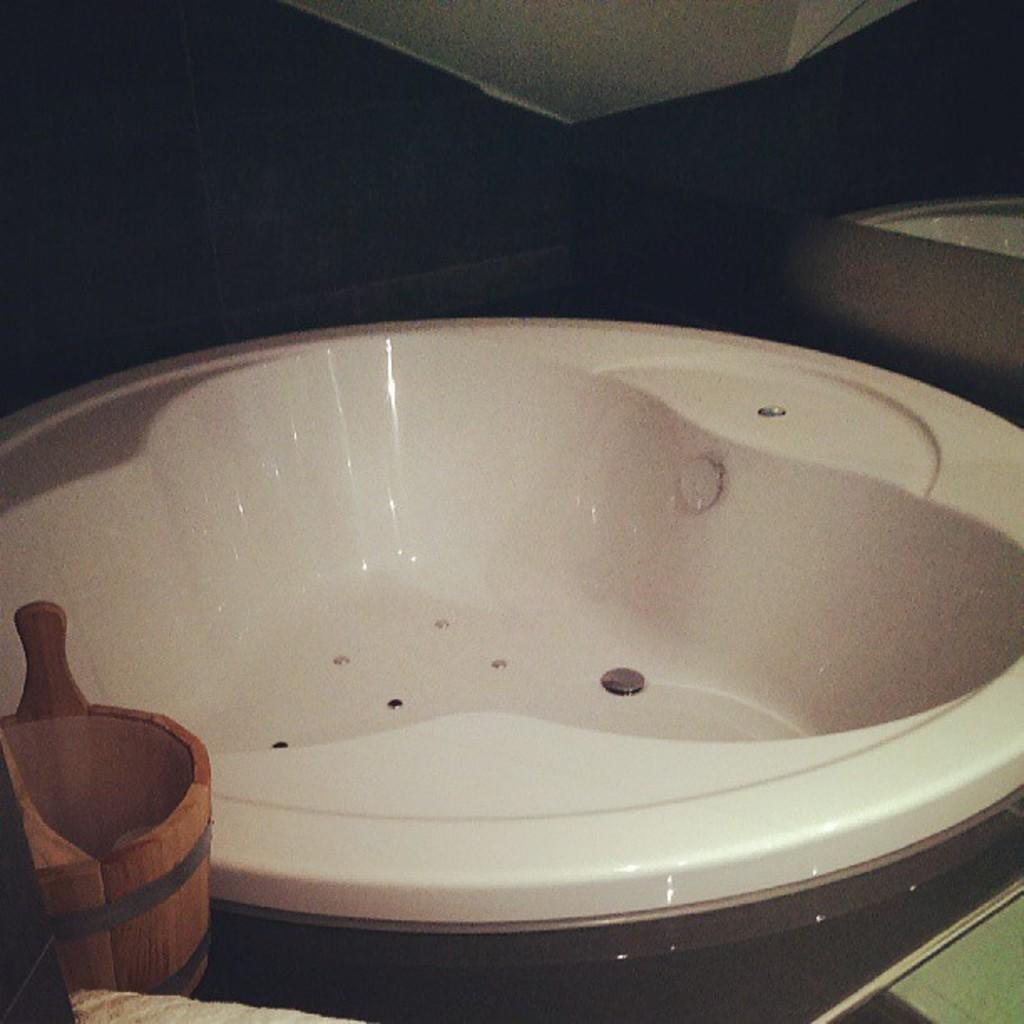What type of object is in the foreground of the image? There is a wooden object in the foreground of the image. How many objects are at the bottom of the image? There are two objects at the bottom of the image. What is the color of the object in the middle of the image? The object in the middle of the image is white. Can you describe the top side of the image? The top side of the image is not clear. What type of guitar is being played in the image? There is no guitar present in the image. Can you describe the pickle's texture in the image? There is no pickle present in the image. 